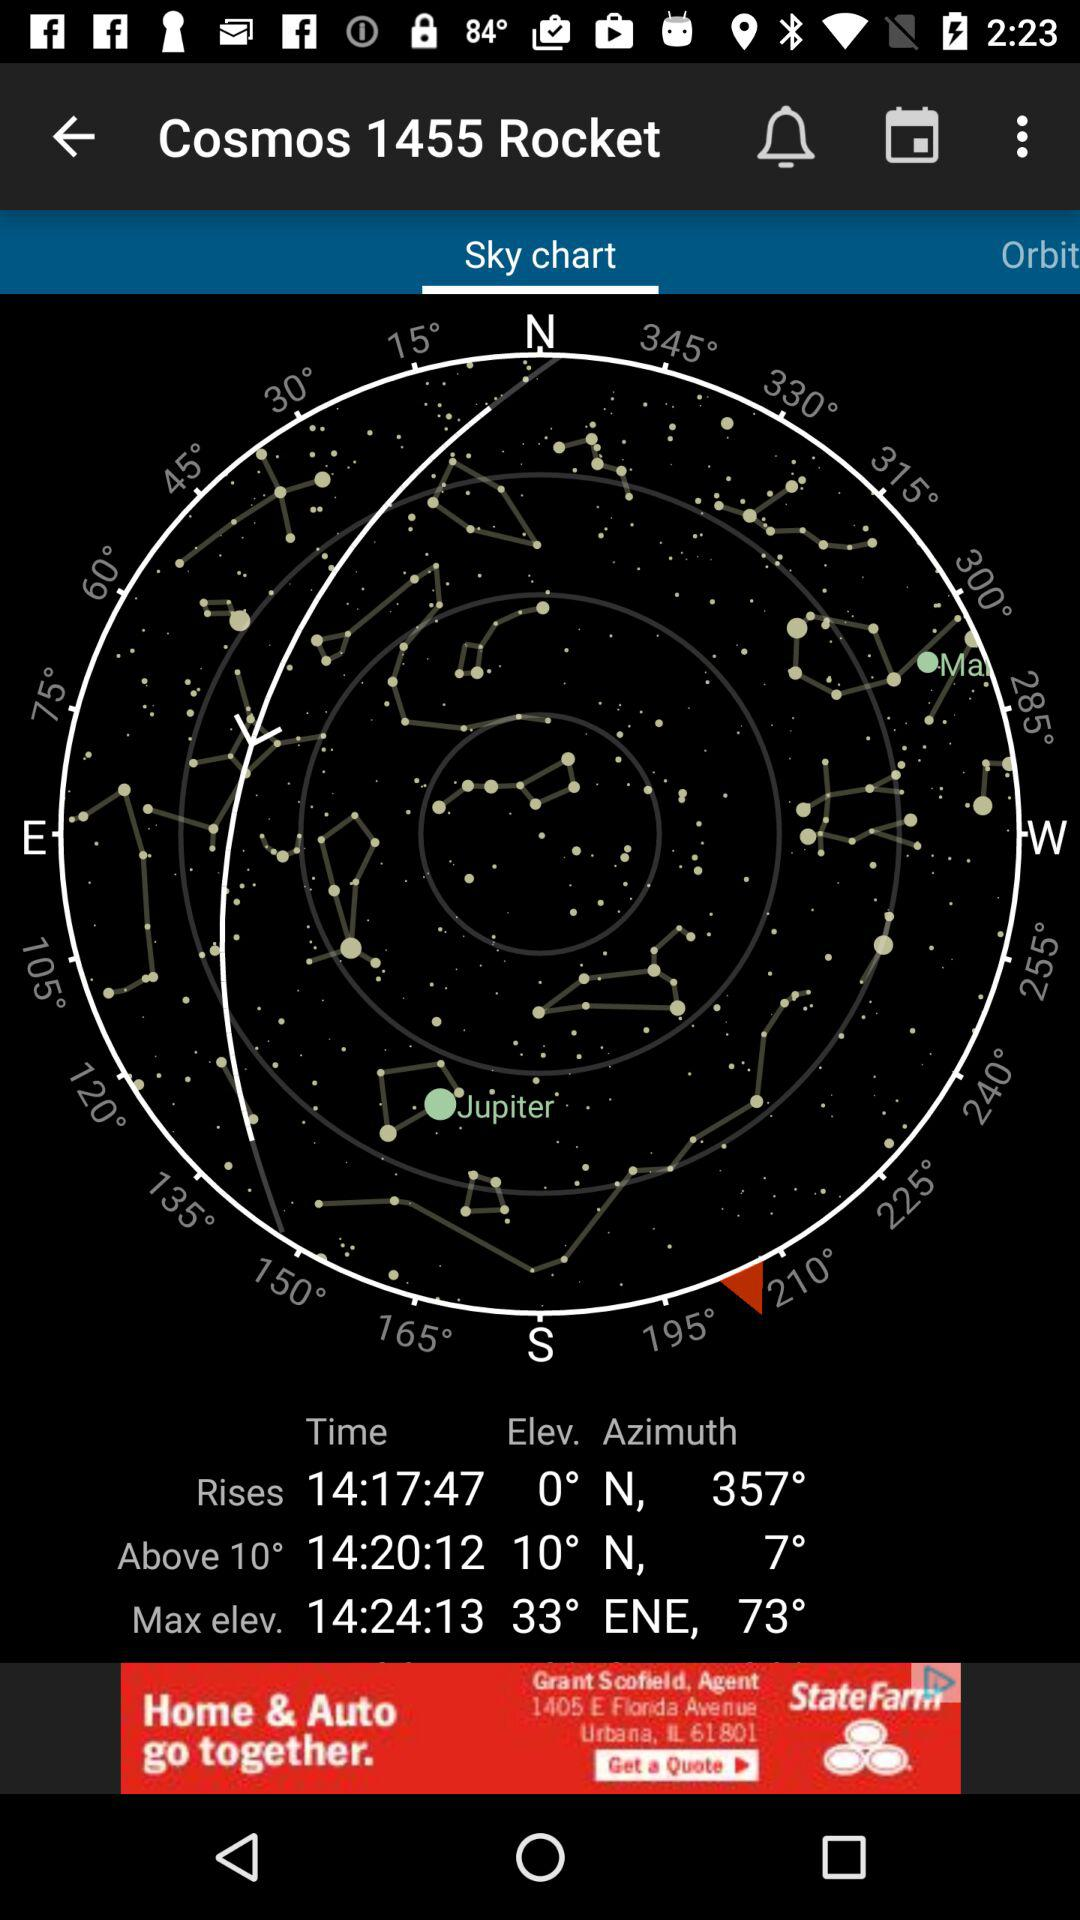How many degrees is the maximum elevation above the horizon?
Answer the question using a single word or phrase. 73° 